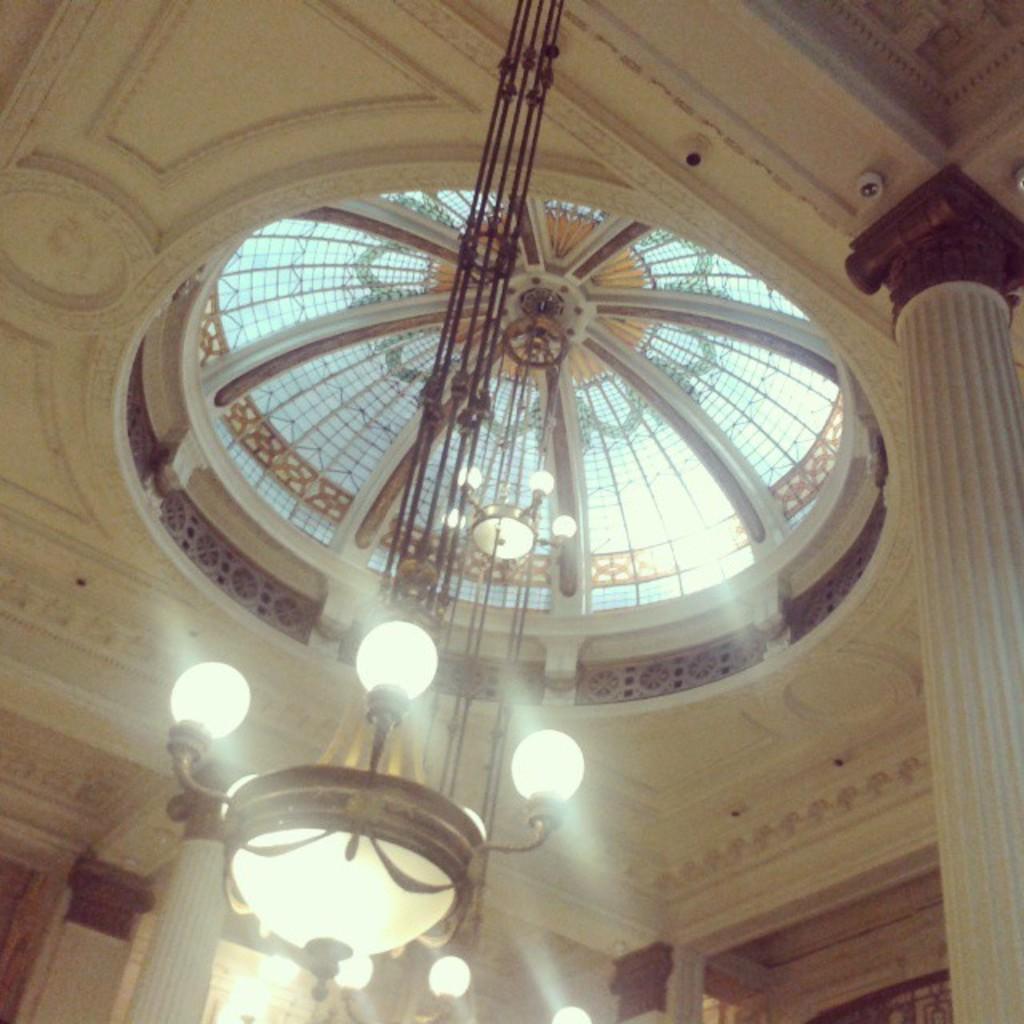Describe this image in one or two sentences. In the picture we can see a ceiling with a dome and glasses to it and to it we can see chandelier and around it we can see pillars. 